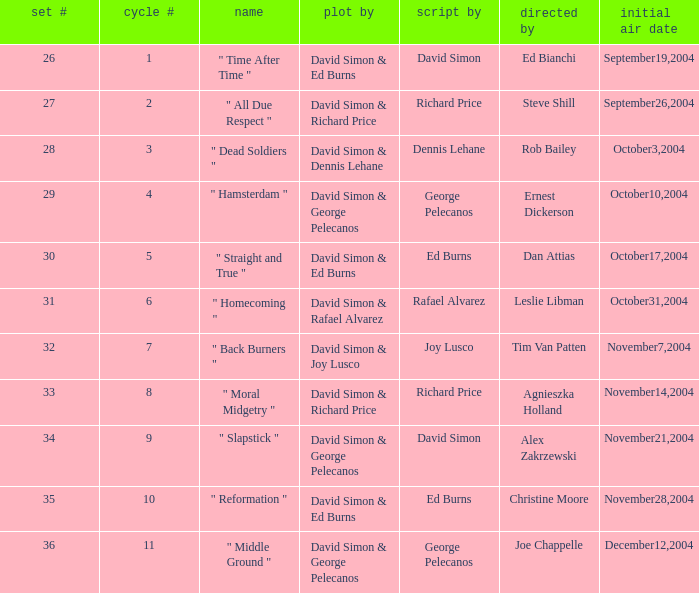Who is the teleplay by when the director is Rob Bailey? Dennis Lehane. 